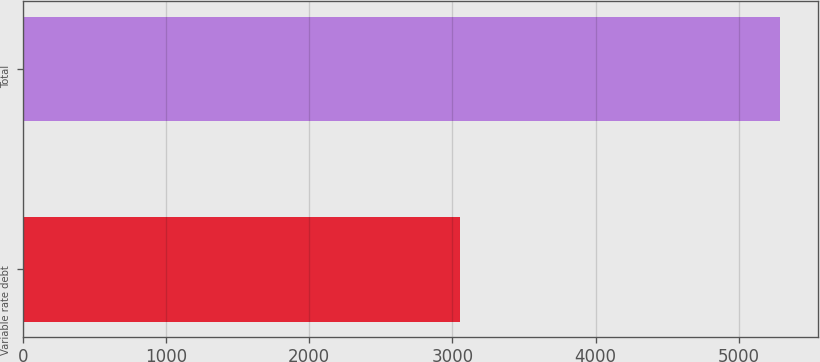Convert chart. <chart><loc_0><loc_0><loc_500><loc_500><bar_chart><fcel>Variable rate debt<fcel>Total<nl><fcel>3051<fcel>5291<nl></chart> 